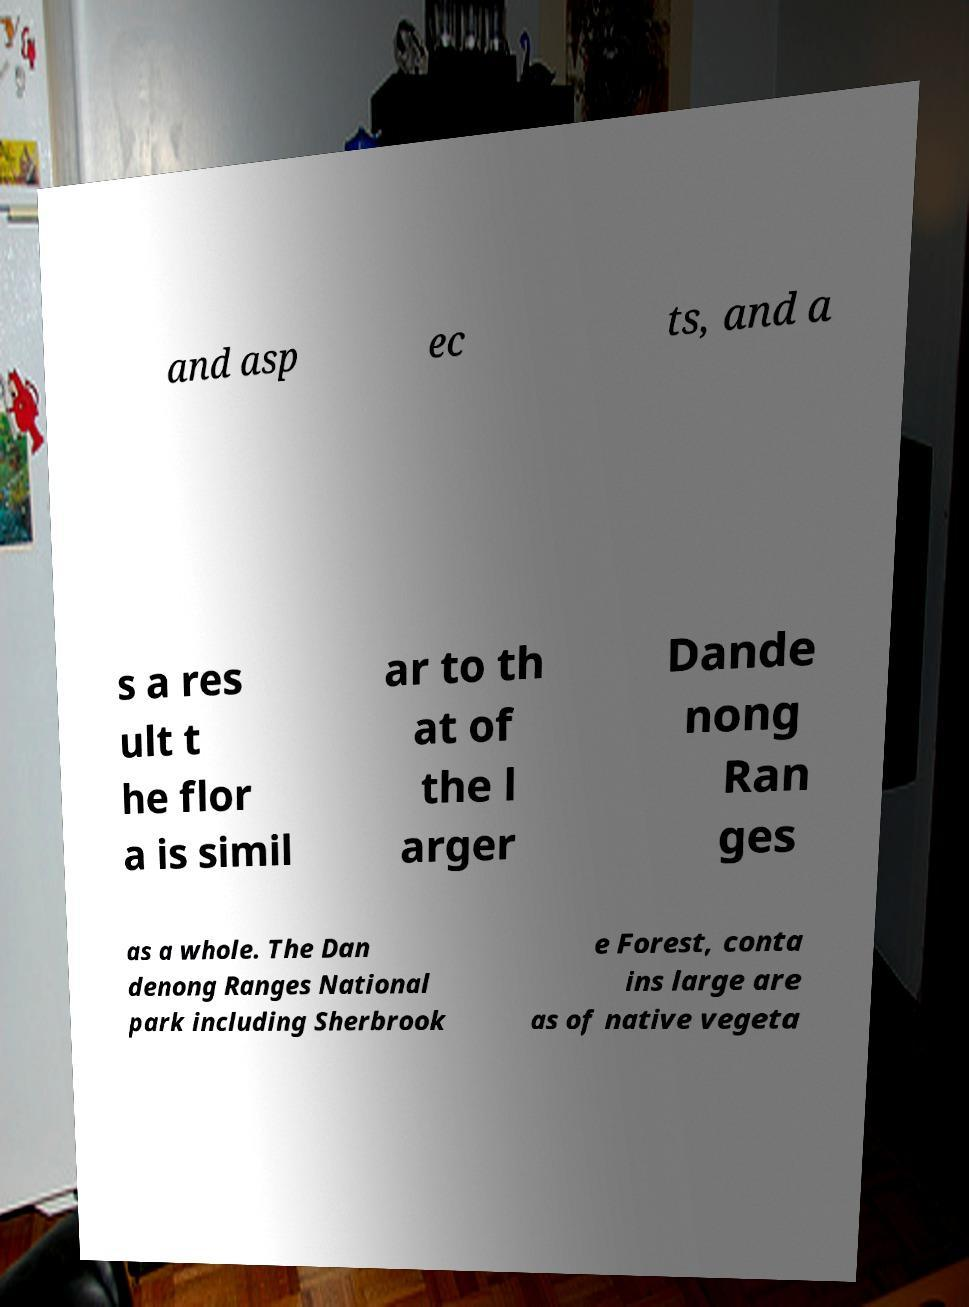Please read and relay the text visible in this image. What does it say? and asp ec ts, and a s a res ult t he flor a is simil ar to th at of the l arger Dande nong Ran ges as a whole. The Dan denong Ranges National park including Sherbrook e Forest, conta ins large are as of native vegeta 